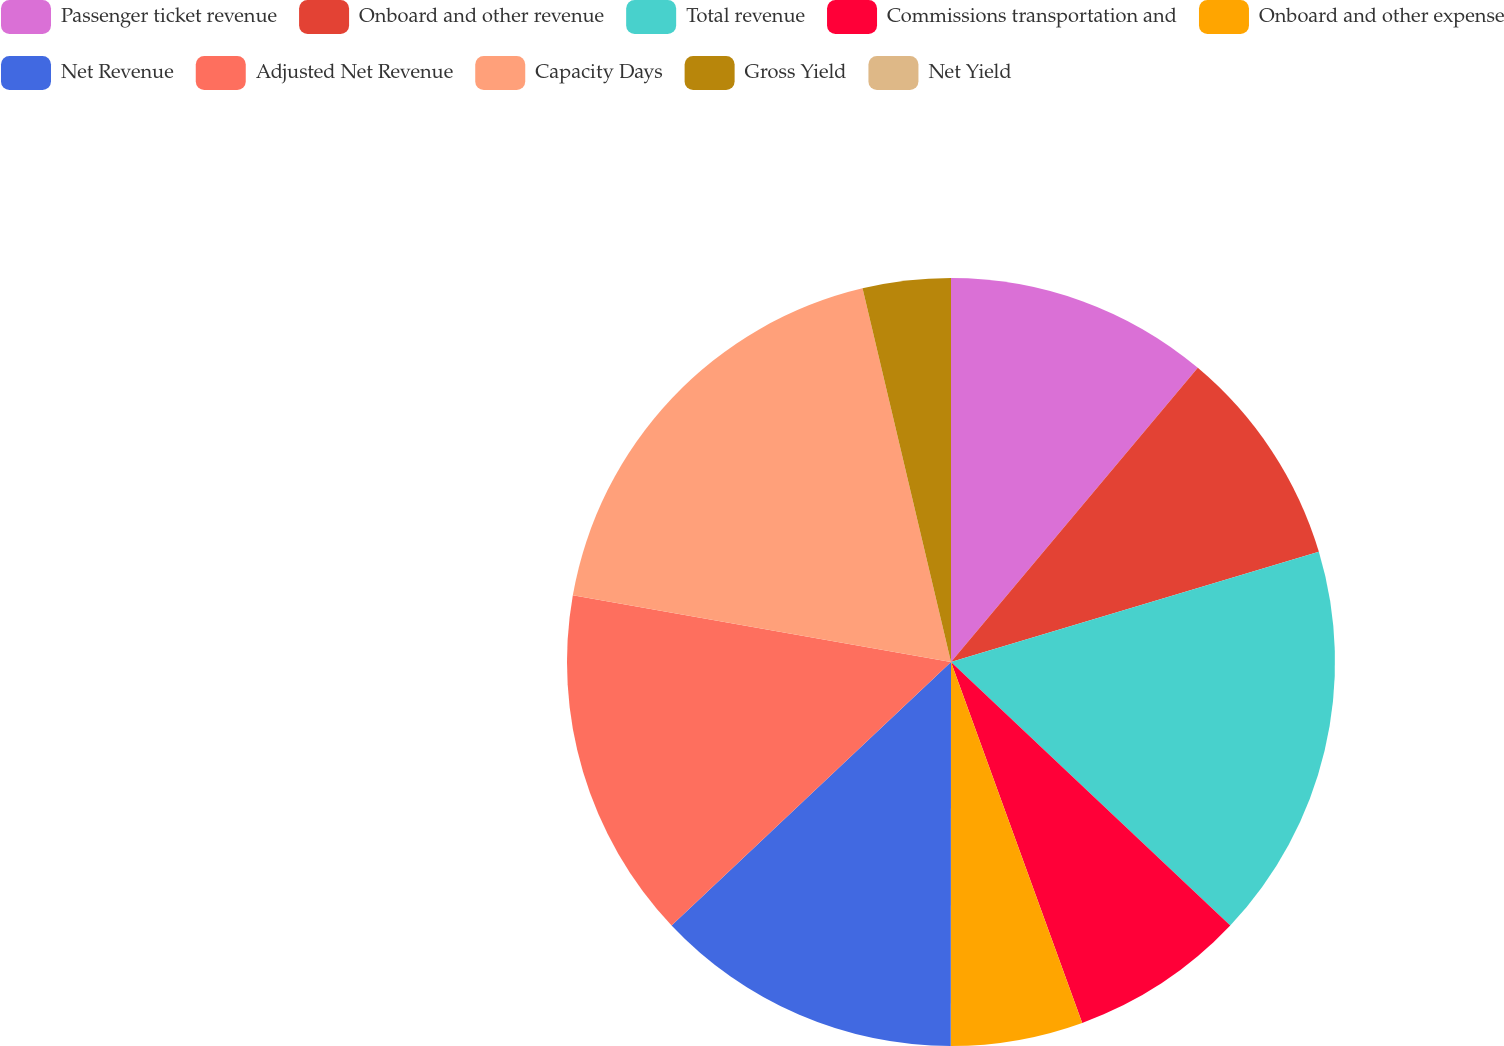Convert chart to OTSL. <chart><loc_0><loc_0><loc_500><loc_500><pie_chart><fcel>Passenger ticket revenue<fcel>Onboard and other revenue<fcel>Total revenue<fcel>Commissions transportation and<fcel>Onboard and other expense<fcel>Net Revenue<fcel>Adjusted Net Revenue<fcel>Capacity Days<fcel>Gross Yield<fcel>Net Yield<nl><fcel>11.11%<fcel>9.26%<fcel>16.67%<fcel>7.41%<fcel>5.56%<fcel>12.96%<fcel>14.81%<fcel>18.52%<fcel>3.7%<fcel>0.0%<nl></chart> 